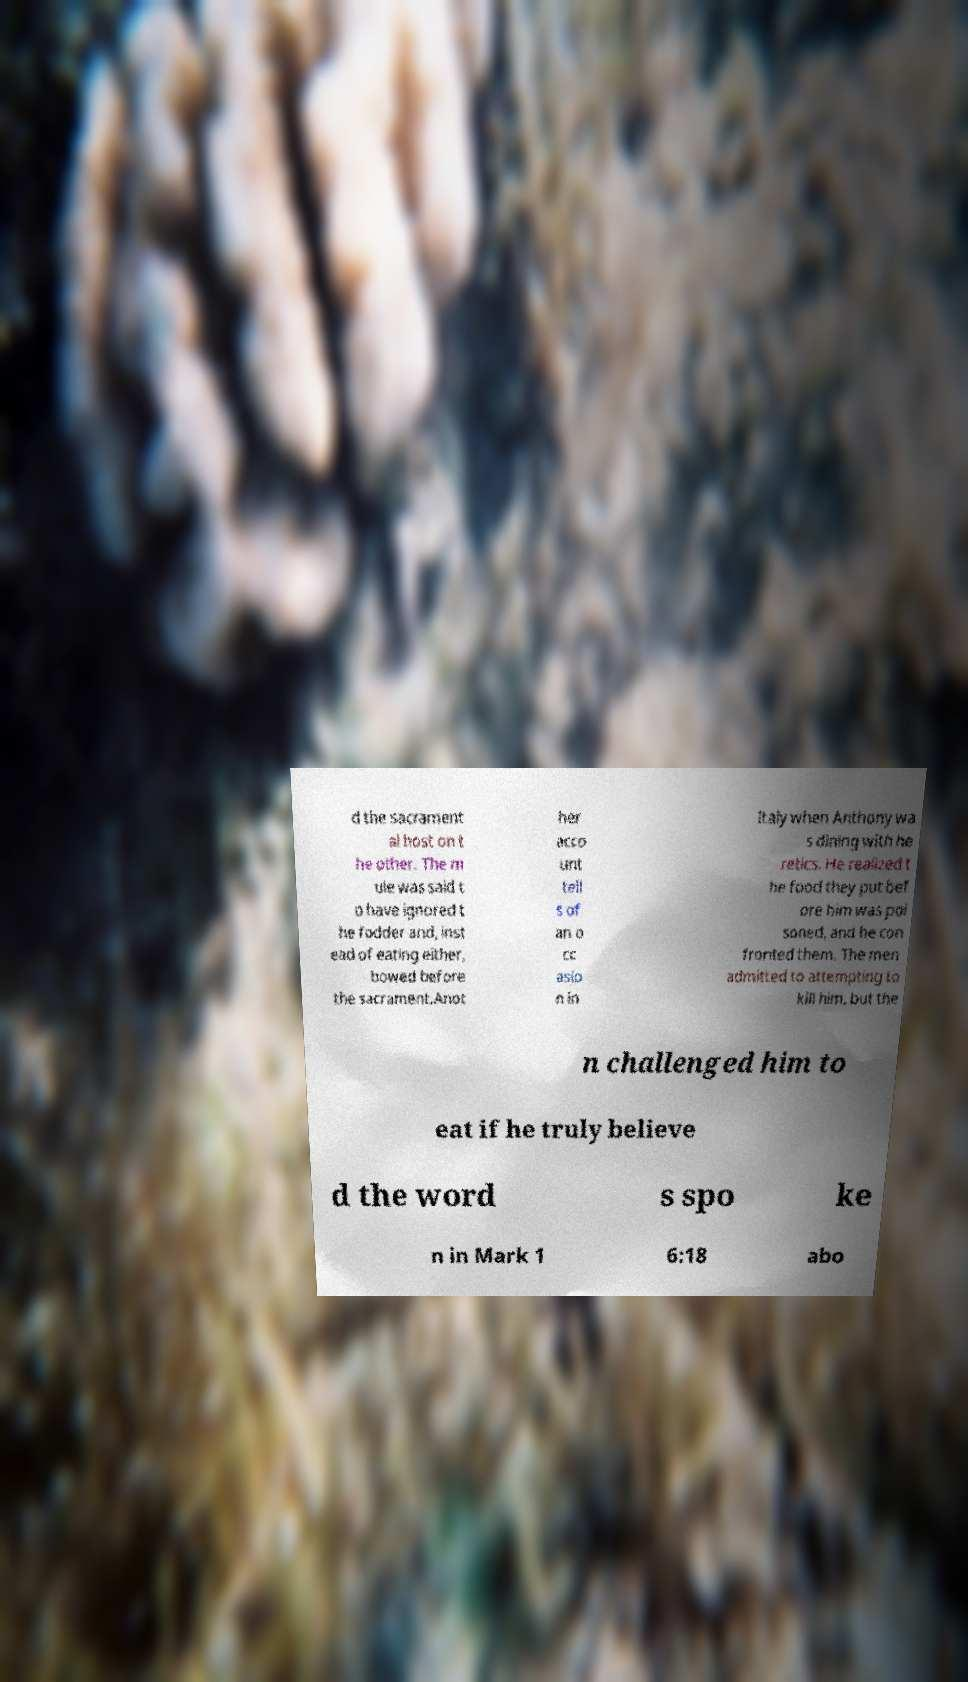What messages or text are displayed in this image? I need them in a readable, typed format. d the sacrament al host on t he other. The m ule was said t o have ignored t he fodder and, inst ead of eating either, bowed before the sacrament.Anot her acco unt tell s of an o cc asio n in Italy when Anthony wa s dining with he retics. He realized t he food they put bef ore him was poi soned, and he con fronted them. The men admitted to attempting to kill him, but the n challenged him to eat if he truly believe d the word s spo ke n in Mark 1 6:18 abo 